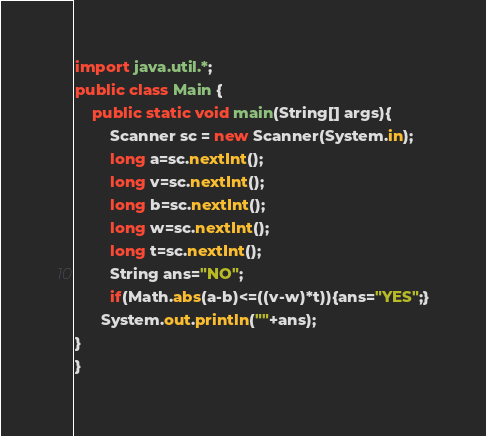Convert code to text. <code><loc_0><loc_0><loc_500><loc_500><_Java_>import java.util.*;
public class Main {
	public static void main(String[] args){
		Scanner sc = new Scanner(System.in);
      	long a=sc.nextInt();	
      	long v=sc.nextInt();	
      	long b=sc.nextInt();	
      	long w=sc.nextInt();	
      	long t=sc.nextInt();	
      	String ans="NO";
      	if(Math.abs(a-b)<=((v-w)*t)){ans="YES";}
      System.out.println(""+ans);
}
}</code> 